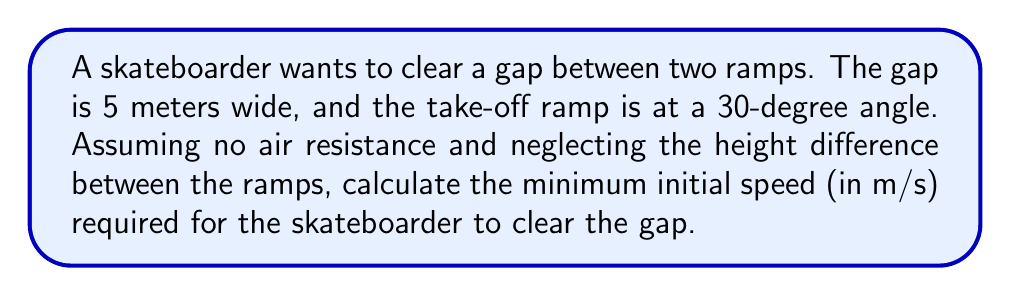Solve this math problem. To solve this problem, we'll use the principles of projectile motion. Here's a step-by-step approach:

1. Identify the relevant equations:
   - Horizontal distance: $x = v_0 \cos(\theta) t$
   - Vertical distance: $y = v_0 \sin(\theta) t - \frac{1}{2}gt^2$

   Where $v_0$ is the initial velocity, $\theta$ is the launch angle, $t$ is time, and $g$ is the acceleration due to gravity (9.8 m/s²).

2. We know that at the end of the gap, $x = 5$ m and $y = 0$ m (assuming the landing ramp is at the same height as the take-off point).

3. From the vertical distance equation, we can find the time of flight:
   $0 = v_0 \sin(30°) t - \frac{1}{2}(9.8)t^2$
   $\frac{1}{2}(9.8)t = v_0 \sin(30°)$
   $t = \frac{2v_0 \sin(30°)}{9.8}$

4. Substitute this time into the horizontal distance equation:
   $5 = v_0 \cos(30°) (\frac{2v_0 \sin(30°)}{9.8})$

5. Simplify and solve for $v_0$:
   $5 = \frac{2v_0^2 \cos(30°) \sin(30°)}{9.8}$
   $5 = \frac{v_0^2 \sin(60°)}{9.8}$
   $v_0^2 = \frac{5 \cdot 9.8}{\sin(60°)}$
   $v_0 = \sqrt{\frac{5 \cdot 9.8}{\sin(60°)}} \approx 7.15$ m/s

Therefore, the minimum initial speed required is approximately 7.15 m/s.
Answer: 7.15 m/s 